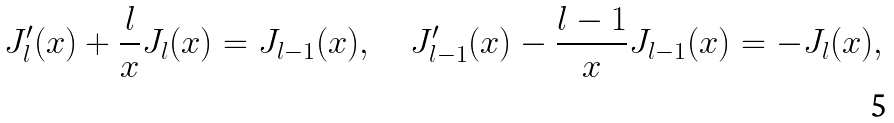<formula> <loc_0><loc_0><loc_500><loc_500>J _ { l } ^ { \prime } ( x ) + \frac { l } { x } J _ { l } ( x ) = J _ { l - 1 } ( x ) , \quad J _ { l - 1 } ^ { \prime } ( x ) - \frac { l - 1 } { x } J _ { l - 1 } ( x ) = - J _ { l } ( x ) ,</formula> 